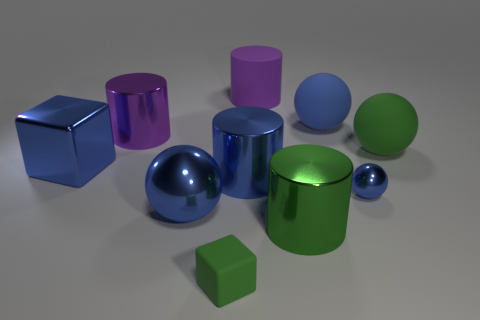What number of objects are either metal objects left of the purple rubber cylinder or big green things that are behind the tiny shiny sphere?
Your answer should be very brief. 5. Do the blue matte object and the green rubber cube have the same size?
Offer a very short reply. No. How many cylinders are either big green things or small gray matte things?
Your answer should be very brief. 1. What number of big objects are both behind the green cylinder and in front of the big green ball?
Offer a very short reply. 3. There is a blue rubber thing; is it the same size as the green rubber object on the left side of the blue rubber ball?
Provide a succinct answer. No. There is a large blue ball behind the tiny blue thing to the right of the shiny block; are there any matte objects that are right of it?
Ensure brevity in your answer.  Yes. There is a big blue sphere in front of the large purple metal cylinder left of the big rubber cylinder; what is it made of?
Provide a succinct answer. Metal. What material is the blue ball that is both in front of the big green rubber ball and left of the tiny metallic sphere?
Your response must be concise. Metal. Are there any other metal things that have the same shape as the small green thing?
Ensure brevity in your answer.  Yes. There is a large blue sphere behind the metal cube; are there any blue rubber spheres that are to the right of it?
Keep it short and to the point. No. 